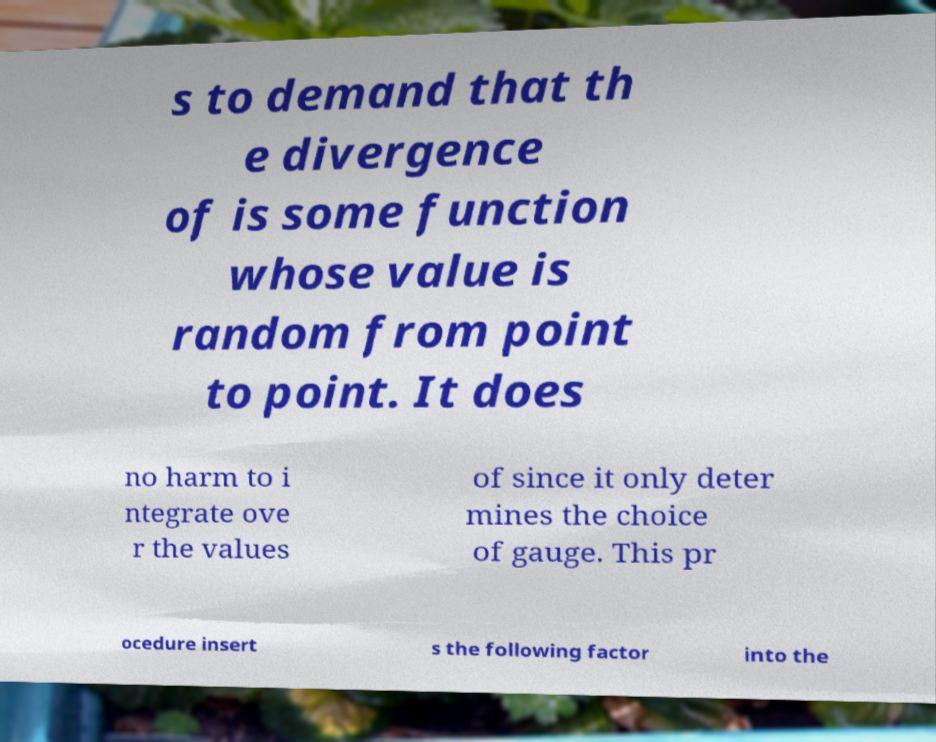Can you read and provide the text displayed in the image?This photo seems to have some interesting text. Can you extract and type it out for me? s to demand that th e divergence of is some function whose value is random from point to point. It does no harm to i ntegrate ove r the values of since it only deter mines the choice of gauge. This pr ocedure insert s the following factor into the 